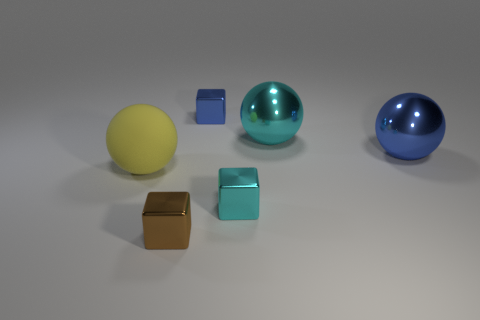Add 2 cyan metal cubes. How many objects exist? 8 Add 5 blue shiny cubes. How many blue shiny cubes are left? 6 Add 6 large yellow rubber things. How many large yellow rubber things exist? 7 Subtract 0 green blocks. How many objects are left? 6 Subtract all shiny balls. Subtract all brown metal cubes. How many objects are left? 3 